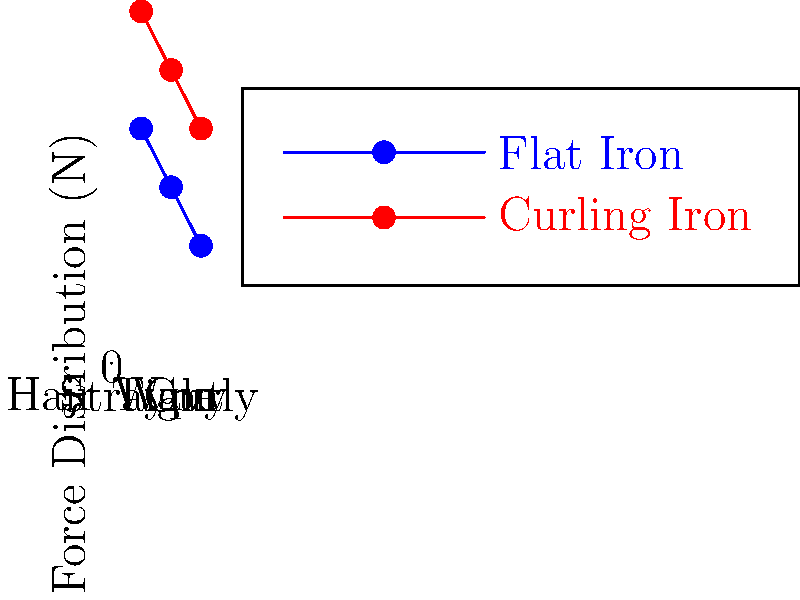Based on the graph showing force distribution on different hair types when using styling tools, which hair type experiences the least force when using a flat iron, and what is the approximate force applied? To answer this question, we need to analyze the graph step-by-step:

1. The graph shows force distribution for two styling tools: flat iron (blue) and curling iron (red).
2. We're interested in the flat iron data (blue line).
3. The x-axis represents three hair types: straight (1), wavy (2), and curly (3).
4. The y-axis shows the force distribution in Newtons (N).
5. For the flat iron (blue line), we can see the following approximate forces:
   - Straight hair: 20 N
   - Wavy hair: 15 N
   - Curly hair: 10 N
6. Among these, curly hair (type 3) experiences the least force.
7. The approximate force applied to curly hair with a flat iron is 10 N.
Answer: Curly hair, 10 N 